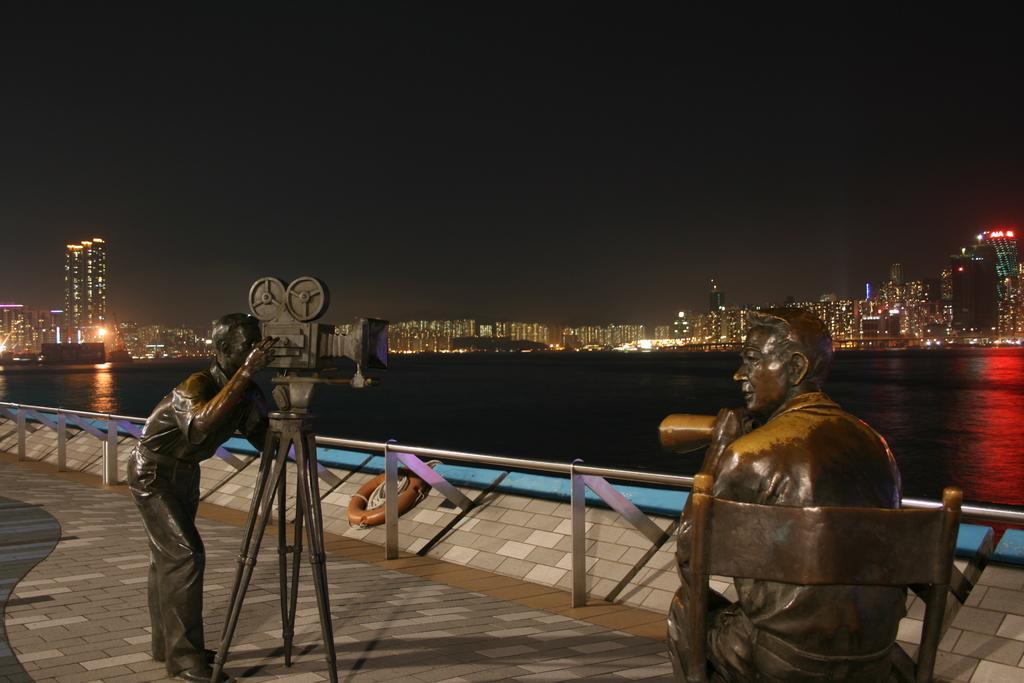Please provide a concise description of this image. In the picture I can see sculptures of men and other things. In the background I can see fence, water, buildings, lights, the sky and some other things. 